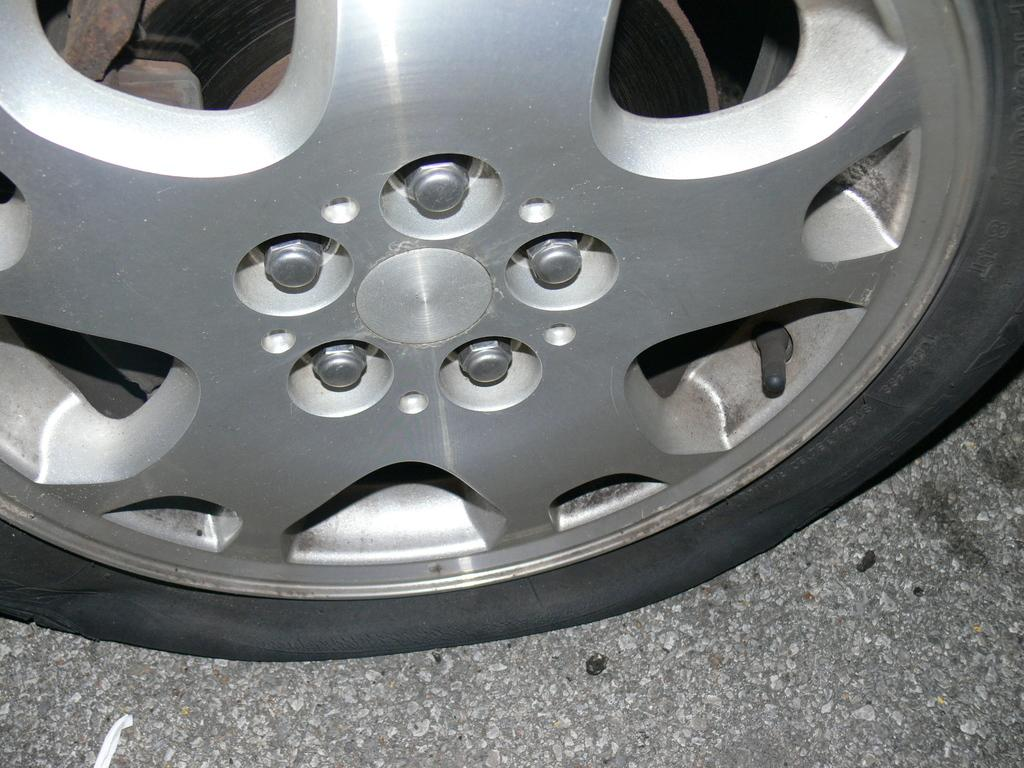What is the main subject of the image? The main subject of the image is a road. What object can be seen on the road in the image? There is a wheel on the road in the image. How many sisters are visible in the image? There are no sisters present in the image. What type of cup is being used to serve the ice cream in the image? There is no ice cream or cup present in the image. Can you tell me where the mother is standing in the image? There is no mother present in the image. 